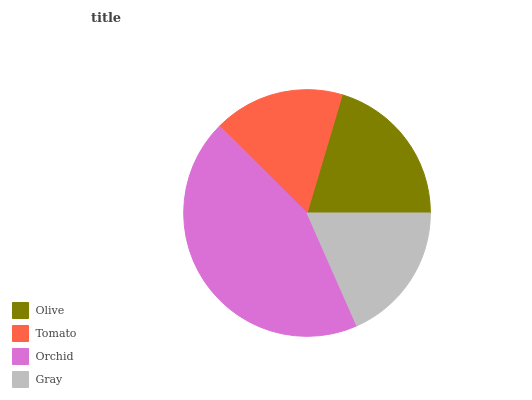Is Tomato the minimum?
Answer yes or no. Yes. Is Orchid the maximum?
Answer yes or no. Yes. Is Orchid the minimum?
Answer yes or no. No. Is Tomato the maximum?
Answer yes or no. No. Is Orchid greater than Tomato?
Answer yes or no. Yes. Is Tomato less than Orchid?
Answer yes or no. Yes. Is Tomato greater than Orchid?
Answer yes or no. No. Is Orchid less than Tomato?
Answer yes or no. No. Is Olive the high median?
Answer yes or no. Yes. Is Gray the low median?
Answer yes or no. Yes. Is Tomato the high median?
Answer yes or no. No. Is Tomato the low median?
Answer yes or no. No. 